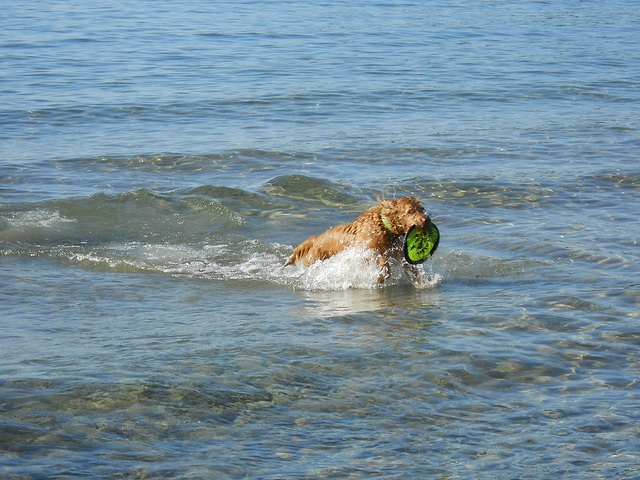Describe the objects in this image and their specific colors. I can see dog in lightblue, tan, and brown tones and frisbee in lightblue, black, darkgreen, and olive tones in this image. 